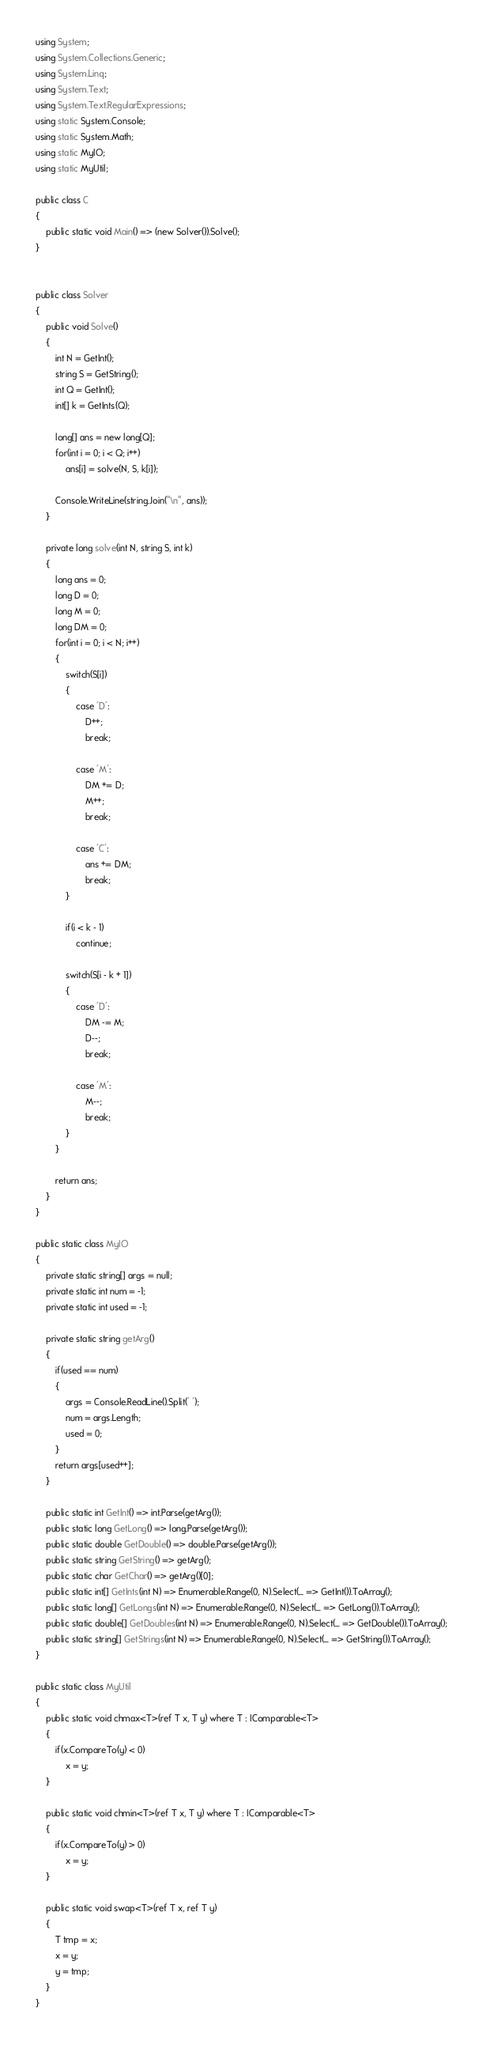<code> <loc_0><loc_0><loc_500><loc_500><_C#_>using System;
using System.Collections.Generic;
using System.Linq;
using System.Text;
using System.Text.RegularExpressions;
using static System.Console;
using static System.Math;
using static MyIO;
using static MyUtil;

public class C
{
	public static void Main() => (new Solver()).Solve();
}


public class Solver
{
	public void Solve()
	{
		int N = GetInt();
		string S = GetString();
		int Q = GetInt();
		int[] k = GetInts(Q);

		long[] ans = new long[Q];
		for(int i = 0; i < Q; i++)
			ans[i] = solve(N, S, k[i]);

		Console.WriteLine(string.Join("\n", ans));	
	}

	private long solve(int N, string S, int k)
	{
		long ans = 0;
		long D = 0;
		long M = 0;
		long DM = 0;
		for(int i = 0; i < N; i++)
		{
			switch(S[i])
			{
				case 'D':
					D++;
					break;

				case 'M':
					DM += D;
					M++;
					break;

				case 'C':
					ans += DM;
					break;
			}

			if(i < k - 1)
				continue;

			switch(S[i - k + 1])
			{
				case 'D':
					DM -= M;
					D--;
					break;

				case 'M':
					M--;
					break;
			}
		}

		return ans;
	}
}

public static class MyIO
{
	private static string[] args = null;
	private static int num = -1;
	private static int used = -1;

	private static string getArg()
	{
		if(used == num)
		{
			args = Console.ReadLine().Split(' ');
			num = args.Length;
			used = 0;
		}
		return args[used++];
	}

	public static int GetInt() => int.Parse(getArg());
	public static long GetLong() => long.Parse(getArg());
	public static double GetDouble() => double.Parse(getArg());
	public static string GetString() => getArg();
	public static char GetChar() => getArg()[0];
	public static int[] GetInts(int N) => Enumerable.Range(0, N).Select(_ => GetInt()).ToArray();
	public static long[] GetLongs(int N) => Enumerable.Range(0, N).Select(_ => GetLong()).ToArray();
	public static double[] GetDoubles(int N) => Enumerable.Range(0, N).Select(_ => GetDouble()).ToArray();
	public static string[] GetStrings(int N) => Enumerable.Range(0, N).Select(_ => GetString()).ToArray();
}

public static class MyUtil
{
	public static void chmax<T>(ref T x, T y) where T : IComparable<T>
	{
		if(x.CompareTo(y) < 0)
			x = y;
	}

	public static void chmin<T>(ref T x, T y) where T : IComparable<T>
	{
		if(x.CompareTo(y) > 0)
			x = y;
	}

	public static void swap<T>(ref T x, ref T y)
	{
		T tmp = x;
		x = y;
		y = tmp;
	}
}</code> 